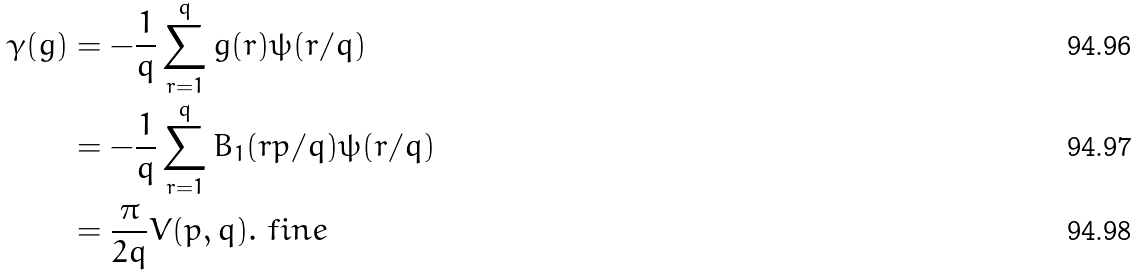Convert formula to latex. <formula><loc_0><loc_0><loc_500><loc_500>\gamma ( g ) & = - \frac { 1 } { q } \sum _ { r = 1 } ^ { q } g ( r ) \psi ( r / q ) \\ & = - \frac { 1 } { q } \sum _ { r = 1 } ^ { q } B _ { 1 } ( r p / q ) \psi ( r / q ) \\ & = \frac { \pi } { 2 q } V ( p , q ) . \ f i n e</formula> 